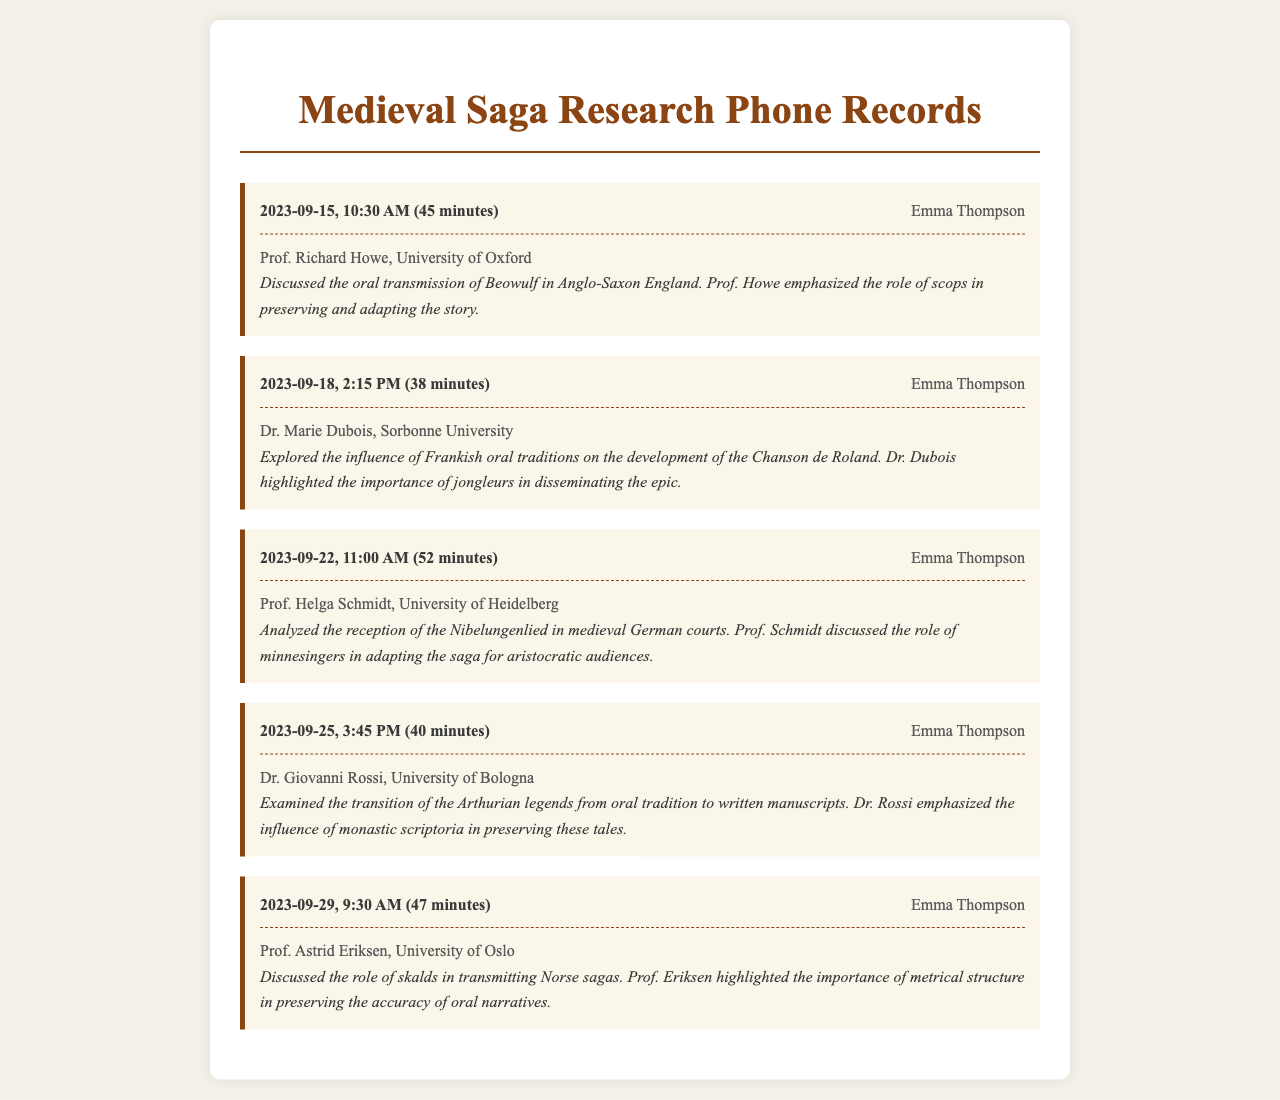What date did Emma Thompson interview Prof. Richard Howe? The date of the interview is included in the record header.
Answer: 2023-09-15 How long was the conversation with Dr. Marie Dubois? The duration of the conversation is specified in the record header.
Answer: 38 minutes What university does Prof. Helga Schmidt belong to? The university is provided in the recipient section of the record.
Answer: University of Heidelberg What topic did Dr. Giovanni Rossi discuss? The main topic of the call is included in the record body.
Answer: Arthurian legends transition Who highlighted the role of jongleurs in disseminating the epic? This information can be found in the record body of the interview with Dr. Marie Dubois.
Answer: Dr. Marie Dubois Which saga's reception was analyzed by Prof. Helga Schmidt? The one discussed is mentioned in the record body of the call.
Answer: Nibelungenlied What aspect of Norse sagas did Prof. Astrid Eriksen focus on? The area of focus is provided in the record body.
Answer: Metrical structure What is the profession of Emma Thompson? The caller's name is provided at the start of each record, indicating her role.
Answer: Researcher What specialization does Dr. Giovanni Rossi have? Based on the content discussed in his interview, this can be inferred.
Answer: Arthurian legends 